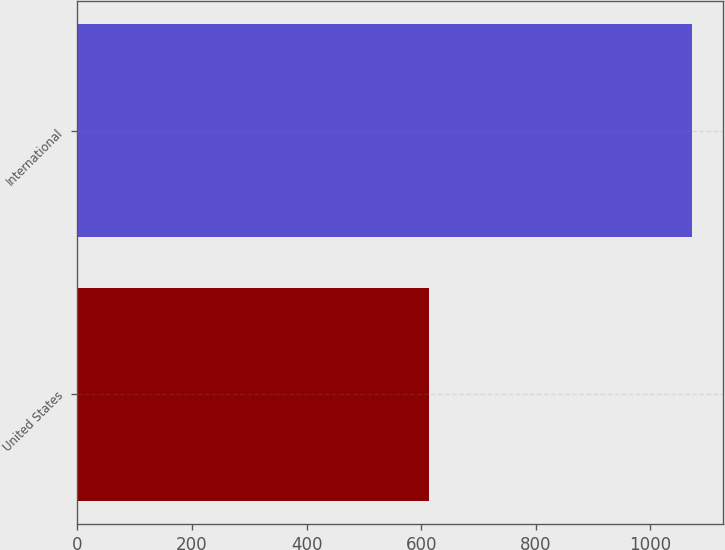Convert chart to OTSL. <chart><loc_0><loc_0><loc_500><loc_500><bar_chart><fcel>United States<fcel>International<nl><fcel>613<fcel>1073<nl></chart> 